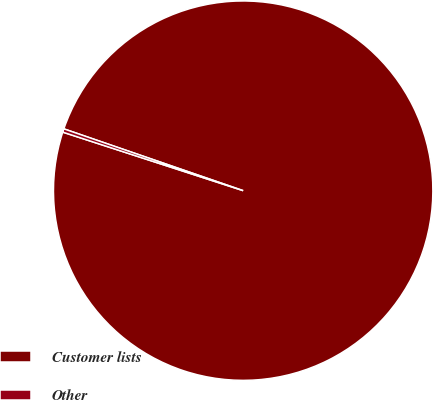Convert chart. <chart><loc_0><loc_0><loc_500><loc_500><pie_chart><fcel>Customer lists<fcel>Other<nl><fcel>99.71%<fcel>0.29%<nl></chart> 